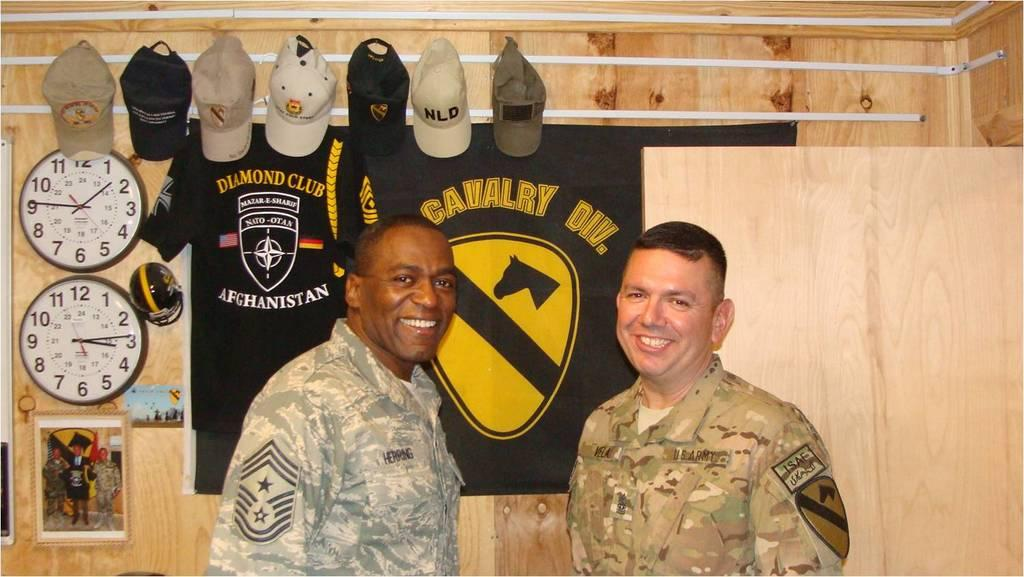<image>
Offer a succinct explanation of the picture presented. Two men in military uniforms are standing by a wall with shirts hanging on it that say Diamond Club Afghanistan and Calvary Div. 